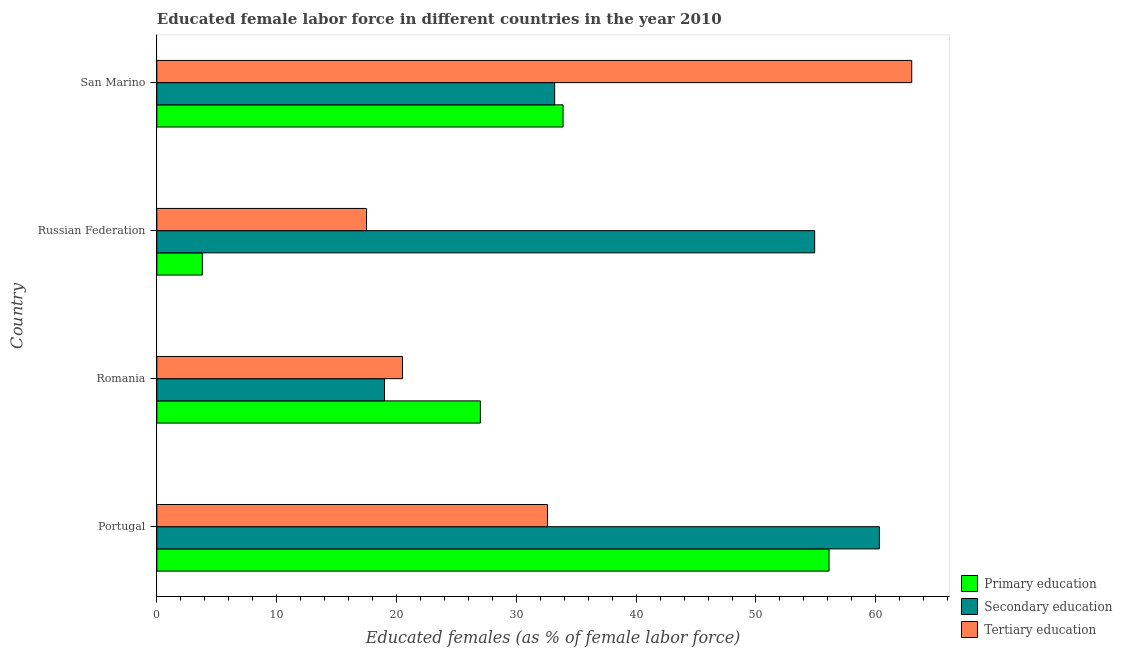Are the number of bars per tick equal to the number of legend labels?
Provide a short and direct response. Yes. How many bars are there on the 3rd tick from the top?
Provide a succinct answer. 3. What is the label of the 3rd group of bars from the top?
Provide a succinct answer. Romania. In how many cases, is the number of bars for a given country not equal to the number of legend labels?
Ensure brevity in your answer.  0. What is the percentage of female labor force who received secondary education in Russian Federation?
Your response must be concise. 54.9. Across all countries, what is the maximum percentage of female labor force who received secondary education?
Provide a short and direct response. 60.3. Across all countries, what is the minimum percentage of female labor force who received primary education?
Provide a succinct answer. 3.8. In which country was the percentage of female labor force who received tertiary education maximum?
Keep it short and to the point. San Marino. In which country was the percentage of female labor force who received primary education minimum?
Keep it short and to the point. Russian Federation. What is the total percentage of female labor force who received tertiary education in the graph?
Provide a succinct answer. 133.6. What is the difference between the percentage of female labor force who received tertiary education in Portugal and that in Russian Federation?
Offer a very short reply. 15.1. What is the difference between the percentage of female labor force who received secondary education in San Marino and the percentage of female labor force who received primary education in Portugal?
Provide a short and direct response. -22.9. What is the average percentage of female labor force who received primary education per country?
Your answer should be very brief. 30.2. What is the difference between the percentage of female labor force who received secondary education and percentage of female labor force who received primary education in Russian Federation?
Your answer should be very brief. 51.1. In how many countries, is the percentage of female labor force who received secondary education greater than 24 %?
Ensure brevity in your answer.  3. What is the ratio of the percentage of female labor force who received tertiary education in Portugal to that in Russian Federation?
Ensure brevity in your answer.  1.86. Is the percentage of female labor force who received tertiary education in Portugal less than that in San Marino?
Your answer should be compact. Yes. Is the difference between the percentage of female labor force who received primary education in Romania and San Marino greater than the difference between the percentage of female labor force who received tertiary education in Romania and San Marino?
Keep it short and to the point. Yes. What is the difference between the highest and the second highest percentage of female labor force who received secondary education?
Offer a very short reply. 5.4. What is the difference between the highest and the lowest percentage of female labor force who received secondary education?
Give a very brief answer. 41.3. What does the 2nd bar from the bottom in San Marino represents?
Make the answer very short. Secondary education. Is it the case that in every country, the sum of the percentage of female labor force who received primary education and percentage of female labor force who received secondary education is greater than the percentage of female labor force who received tertiary education?
Provide a succinct answer. Yes. How many bars are there?
Your answer should be compact. 12. Are all the bars in the graph horizontal?
Provide a succinct answer. Yes. What is the difference between two consecutive major ticks on the X-axis?
Your response must be concise. 10. Does the graph contain grids?
Your answer should be compact. No. How are the legend labels stacked?
Provide a short and direct response. Vertical. What is the title of the graph?
Keep it short and to the point. Educated female labor force in different countries in the year 2010. Does "ICT services" appear as one of the legend labels in the graph?
Offer a terse response. No. What is the label or title of the X-axis?
Offer a terse response. Educated females (as % of female labor force). What is the label or title of the Y-axis?
Offer a terse response. Country. What is the Educated females (as % of female labor force) of Primary education in Portugal?
Offer a terse response. 56.1. What is the Educated females (as % of female labor force) of Secondary education in Portugal?
Offer a very short reply. 60.3. What is the Educated females (as % of female labor force) of Tertiary education in Portugal?
Give a very brief answer. 32.6. What is the Educated females (as % of female labor force) of Primary education in Romania?
Offer a very short reply. 27. What is the Educated females (as % of female labor force) in Tertiary education in Romania?
Provide a short and direct response. 20.5. What is the Educated females (as % of female labor force) in Primary education in Russian Federation?
Give a very brief answer. 3.8. What is the Educated females (as % of female labor force) of Secondary education in Russian Federation?
Keep it short and to the point. 54.9. What is the Educated females (as % of female labor force) in Primary education in San Marino?
Provide a succinct answer. 33.9. What is the Educated females (as % of female labor force) of Secondary education in San Marino?
Your answer should be compact. 33.2. Across all countries, what is the maximum Educated females (as % of female labor force) in Primary education?
Make the answer very short. 56.1. Across all countries, what is the maximum Educated females (as % of female labor force) of Secondary education?
Provide a short and direct response. 60.3. Across all countries, what is the minimum Educated females (as % of female labor force) in Primary education?
Ensure brevity in your answer.  3.8. Across all countries, what is the minimum Educated females (as % of female labor force) in Secondary education?
Your response must be concise. 19. What is the total Educated females (as % of female labor force) of Primary education in the graph?
Provide a short and direct response. 120.8. What is the total Educated females (as % of female labor force) of Secondary education in the graph?
Your answer should be very brief. 167.4. What is the total Educated females (as % of female labor force) in Tertiary education in the graph?
Provide a short and direct response. 133.6. What is the difference between the Educated females (as % of female labor force) in Primary education in Portugal and that in Romania?
Keep it short and to the point. 29.1. What is the difference between the Educated females (as % of female labor force) of Secondary education in Portugal and that in Romania?
Offer a very short reply. 41.3. What is the difference between the Educated females (as % of female labor force) in Tertiary education in Portugal and that in Romania?
Keep it short and to the point. 12.1. What is the difference between the Educated females (as % of female labor force) in Primary education in Portugal and that in Russian Federation?
Give a very brief answer. 52.3. What is the difference between the Educated females (as % of female labor force) of Tertiary education in Portugal and that in Russian Federation?
Give a very brief answer. 15.1. What is the difference between the Educated females (as % of female labor force) in Primary education in Portugal and that in San Marino?
Your answer should be compact. 22.2. What is the difference between the Educated females (as % of female labor force) in Secondary education in Portugal and that in San Marino?
Your response must be concise. 27.1. What is the difference between the Educated females (as % of female labor force) of Tertiary education in Portugal and that in San Marino?
Your response must be concise. -30.4. What is the difference between the Educated females (as % of female labor force) in Primary education in Romania and that in Russian Federation?
Make the answer very short. 23.2. What is the difference between the Educated females (as % of female labor force) of Secondary education in Romania and that in Russian Federation?
Your answer should be very brief. -35.9. What is the difference between the Educated females (as % of female labor force) of Tertiary education in Romania and that in Russian Federation?
Make the answer very short. 3. What is the difference between the Educated females (as % of female labor force) of Primary education in Romania and that in San Marino?
Provide a short and direct response. -6.9. What is the difference between the Educated females (as % of female labor force) of Secondary education in Romania and that in San Marino?
Offer a very short reply. -14.2. What is the difference between the Educated females (as % of female labor force) of Tertiary education in Romania and that in San Marino?
Your answer should be compact. -42.5. What is the difference between the Educated females (as % of female labor force) in Primary education in Russian Federation and that in San Marino?
Your answer should be compact. -30.1. What is the difference between the Educated females (as % of female labor force) of Secondary education in Russian Federation and that in San Marino?
Keep it short and to the point. 21.7. What is the difference between the Educated females (as % of female labor force) in Tertiary education in Russian Federation and that in San Marino?
Keep it short and to the point. -45.5. What is the difference between the Educated females (as % of female labor force) of Primary education in Portugal and the Educated females (as % of female labor force) of Secondary education in Romania?
Keep it short and to the point. 37.1. What is the difference between the Educated females (as % of female labor force) of Primary education in Portugal and the Educated females (as % of female labor force) of Tertiary education in Romania?
Offer a terse response. 35.6. What is the difference between the Educated females (as % of female labor force) of Secondary education in Portugal and the Educated females (as % of female labor force) of Tertiary education in Romania?
Provide a succinct answer. 39.8. What is the difference between the Educated females (as % of female labor force) of Primary education in Portugal and the Educated females (as % of female labor force) of Secondary education in Russian Federation?
Keep it short and to the point. 1.2. What is the difference between the Educated females (as % of female labor force) in Primary education in Portugal and the Educated females (as % of female labor force) in Tertiary education in Russian Federation?
Ensure brevity in your answer.  38.6. What is the difference between the Educated females (as % of female labor force) of Secondary education in Portugal and the Educated females (as % of female labor force) of Tertiary education in Russian Federation?
Your answer should be compact. 42.8. What is the difference between the Educated females (as % of female labor force) in Primary education in Portugal and the Educated females (as % of female labor force) in Secondary education in San Marino?
Offer a terse response. 22.9. What is the difference between the Educated females (as % of female labor force) in Secondary education in Portugal and the Educated females (as % of female labor force) in Tertiary education in San Marino?
Offer a terse response. -2.7. What is the difference between the Educated females (as % of female labor force) in Primary education in Romania and the Educated females (as % of female labor force) in Secondary education in Russian Federation?
Your answer should be very brief. -27.9. What is the difference between the Educated females (as % of female labor force) of Secondary education in Romania and the Educated females (as % of female labor force) of Tertiary education in Russian Federation?
Offer a very short reply. 1.5. What is the difference between the Educated females (as % of female labor force) of Primary education in Romania and the Educated females (as % of female labor force) of Tertiary education in San Marino?
Ensure brevity in your answer.  -36. What is the difference between the Educated females (as % of female labor force) of Secondary education in Romania and the Educated females (as % of female labor force) of Tertiary education in San Marino?
Give a very brief answer. -44. What is the difference between the Educated females (as % of female labor force) of Primary education in Russian Federation and the Educated females (as % of female labor force) of Secondary education in San Marino?
Ensure brevity in your answer.  -29.4. What is the difference between the Educated females (as % of female labor force) in Primary education in Russian Federation and the Educated females (as % of female labor force) in Tertiary education in San Marino?
Offer a terse response. -59.2. What is the average Educated females (as % of female labor force) of Primary education per country?
Offer a very short reply. 30.2. What is the average Educated females (as % of female labor force) of Secondary education per country?
Offer a terse response. 41.85. What is the average Educated females (as % of female labor force) in Tertiary education per country?
Keep it short and to the point. 33.4. What is the difference between the Educated females (as % of female labor force) of Primary education and Educated females (as % of female labor force) of Tertiary education in Portugal?
Ensure brevity in your answer.  23.5. What is the difference between the Educated females (as % of female labor force) in Secondary education and Educated females (as % of female labor force) in Tertiary education in Portugal?
Provide a succinct answer. 27.7. What is the difference between the Educated females (as % of female labor force) in Primary education and Educated females (as % of female labor force) in Secondary education in Romania?
Your answer should be very brief. 8. What is the difference between the Educated females (as % of female labor force) of Secondary education and Educated females (as % of female labor force) of Tertiary education in Romania?
Keep it short and to the point. -1.5. What is the difference between the Educated females (as % of female labor force) in Primary education and Educated females (as % of female labor force) in Secondary education in Russian Federation?
Your answer should be very brief. -51.1. What is the difference between the Educated females (as % of female labor force) of Primary education and Educated females (as % of female labor force) of Tertiary education in Russian Federation?
Give a very brief answer. -13.7. What is the difference between the Educated females (as % of female labor force) of Secondary education and Educated females (as % of female labor force) of Tertiary education in Russian Federation?
Offer a terse response. 37.4. What is the difference between the Educated females (as % of female labor force) of Primary education and Educated females (as % of female labor force) of Secondary education in San Marino?
Ensure brevity in your answer.  0.7. What is the difference between the Educated females (as % of female labor force) of Primary education and Educated females (as % of female labor force) of Tertiary education in San Marino?
Keep it short and to the point. -29.1. What is the difference between the Educated females (as % of female labor force) of Secondary education and Educated females (as % of female labor force) of Tertiary education in San Marino?
Give a very brief answer. -29.8. What is the ratio of the Educated females (as % of female labor force) of Primary education in Portugal to that in Romania?
Provide a short and direct response. 2.08. What is the ratio of the Educated females (as % of female labor force) of Secondary education in Portugal to that in Romania?
Offer a very short reply. 3.17. What is the ratio of the Educated females (as % of female labor force) in Tertiary education in Portugal to that in Romania?
Make the answer very short. 1.59. What is the ratio of the Educated females (as % of female labor force) of Primary education in Portugal to that in Russian Federation?
Make the answer very short. 14.76. What is the ratio of the Educated females (as % of female labor force) in Secondary education in Portugal to that in Russian Federation?
Make the answer very short. 1.1. What is the ratio of the Educated females (as % of female labor force) of Tertiary education in Portugal to that in Russian Federation?
Keep it short and to the point. 1.86. What is the ratio of the Educated females (as % of female labor force) of Primary education in Portugal to that in San Marino?
Keep it short and to the point. 1.65. What is the ratio of the Educated females (as % of female labor force) in Secondary education in Portugal to that in San Marino?
Offer a terse response. 1.82. What is the ratio of the Educated females (as % of female labor force) of Tertiary education in Portugal to that in San Marino?
Your answer should be compact. 0.52. What is the ratio of the Educated females (as % of female labor force) of Primary education in Romania to that in Russian Federation?
Provide a succinct answer. 7.11. What is the ratio of the Educated females (as % of female labor force) of Secondary education in Romania to that in Russian Federation?
Offer a terse response. 0.35. What is the ratio of the Educated females (as % of female labor force) of Tertiary education in Romania to that in Russian Federation?
Provide a short and direct response. 1.17. What is the ratio of the Educated females (as % of female labor force) of Primary education in Romania to that in San Marino?
Provide a short and direct response. 0.8. What is the ratio of the Educated females (as % of female labor force) of Secondary education in Romania to that in San Marino?
Your answer should be very brief. 0.57. What is the ratio of the Educated females (as % of female labor force) in Tertiary education in Romania to that in San Marino?
Provide a short and direct response. 0.33. What is the ratio of the Educated females (as % of female labor force) in Primary education in Russian Federation to that in San Marino?
Make the answer very short. 0.11. What is the ratio of the Educated females (as % of female labor force) of Secondary education in Russian Federation to that in San Marino?
Offer a terse response. 1.65. What is the ratio of the Educated females (as % of female labor force) of Tertiary education in Russian Federation to that in San Marino?
Ensure brevity in your answer.  0.28. What is the difference between the highest and the second highest Educated females (as % of female labor force) of Primary education?
Your response must be concise. 22.2. What is the difference between the highest and the second highest Educated females (as % of female labor force) in Tertiary education?
Provide a short and direct response. 30.4. What is the difference between the highest and the lowest Educated females (as % of female labor force) of Primary education?
Your response must be concise. 52.3. What is the difference between the highest and the lowest Educated females (as % of female labor force) of Secondary education?
Your answer should be very brief. 41.3. What is the difference between the highest and the lowest Educated females (as % of female labor force) in Tertiary education?
Give a very brief answer. 45.5. 